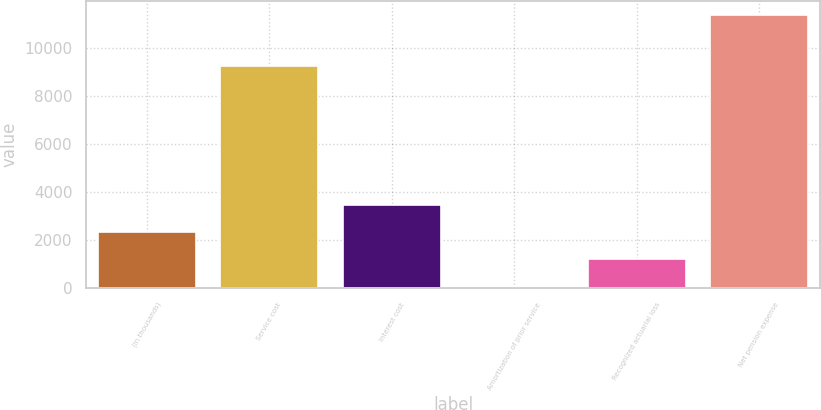Convert chart to OTSL. <chart><loc_0><loc_0><loc_500><loc_500><bar_chart><fcel>(In thousands)<fcel>Service cost<fcel>Interest cost<fcel>Amortization of prior service<fcel>Recognized actuarial loss<fcel>Net pension expense<nl><fcel>2328.8<fcel>9260<fcel>3462.7<fcel>61<fcel>1194.9<fcel>11400<nl></chart> 